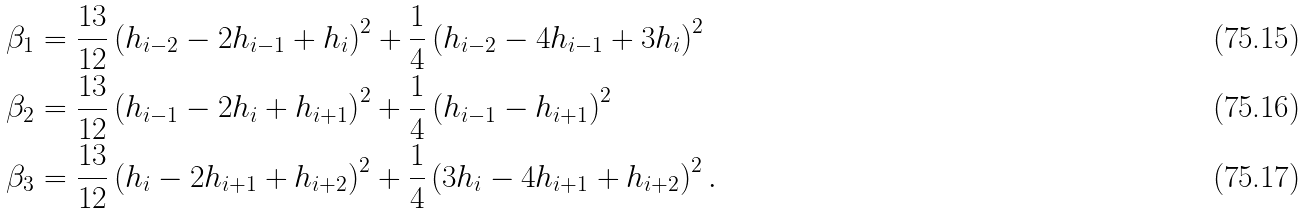<formula> <loc_0><loc_0><loc_500><loc_500>\beta _ { 1 } & = \frac { 1 3 } { 1 2 } \left ( h _ { i - 2 } - 2 h _ { i - 1 } + h _ { i } \right ) ^ { 2 } + \frac { 1 } { 4 } \left ( h _ { i - 2 } - 4 h _ { i - 1 } + 3 h _ { i } \right ) ^ { 2 } \\ \beta _ { 2 } & = \frac { 1 3 } { 1 2 } \left ( h _ { i - 1 } - 2 h _ { i } + h _ { i + 1 } \right ) ^ { 2 } + \frac { 1 } { 4 } \left ( h _ { i - 1 } - h _ { i + 1 } \right ) ^ { 2 } \\ \beta _ { 3 } & = \frac { 1 3 } { 1 2 } \left ( h _ { i } - 2 h _ { i + 1 } + h _ { i + 2 } \right ) ^ { 2 } + \frac { 1 } { 4 } \left ( 3 h _ { i } - 4 h _ { i + 1 } + h _ { i + 2 } \right ) ^ { 2 } .</formula> 